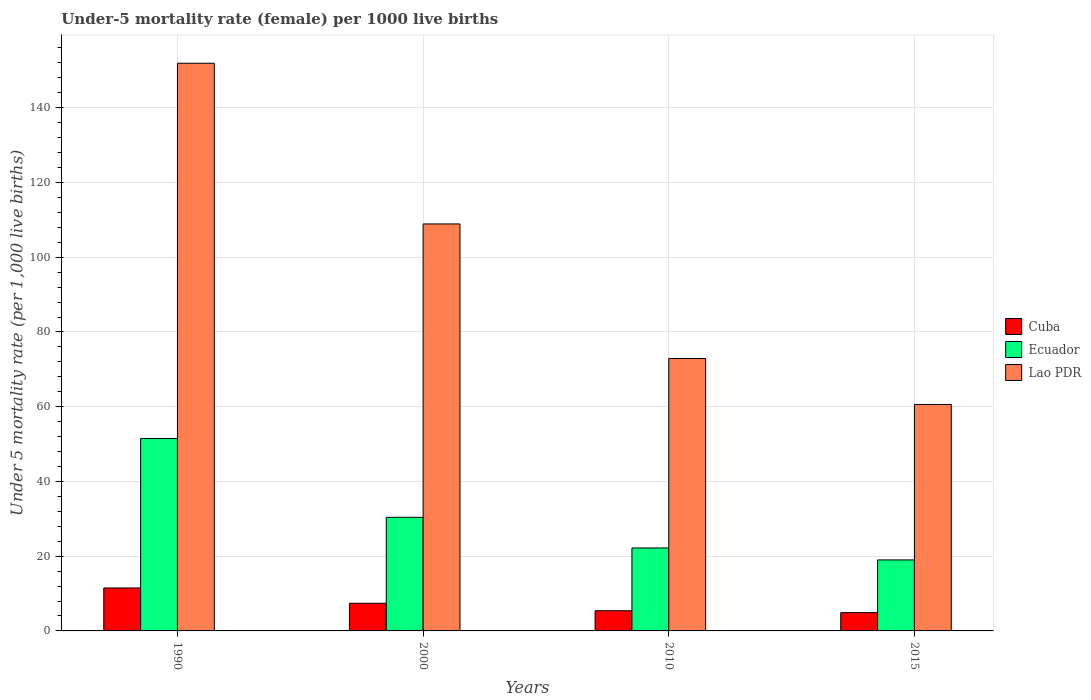How many groups of bars are there?
Your answer should be very brief. 4. Are the number of bars on each tick of the X-axis equal?
Keep it short and to the point. Yes. How many bars are there on the 3rd tick from the left?
Your answer should be very brief. 3. How many bars are there on the 4th tick from the right?
Offer a very short reply. 3. What is the under-five mortality rate in Cuba in 2000?
Offer a very short reply. 7.4. Across all years, what is the maximum under-five mortality rate in Ecuador?
Keep it short and to the point. 51.5. Across all years, what is the minimum under-five mortality rate in Lao PDR?
Your answer should be very brief. 60.6. In which year was the under-five mortality rate in Ecuador minimum?
Your answer should be very brief. 2015. What is the total under-five mortality rate in Lao PDR in the graph?
Provide a short and direct response. 394.3. What is the difference between the under-five mortality rate in Lao PDR in 1990 and that in 2015?
Provide a succinct answer. 91.3. What is the difference between the under-five mortality rate in Lao PDR in 2010 and the under-five mortality rate in Cuba in 1990?
Keep it short and to the point. 61.4. What is the average under-five mortality rate in Lao PDR per year?
Offer a very short reply. 98.58. In how many years, is the under-five mortality rate in Ecuador greater than 28?
Make the answer very short. 2. What is the ratio of the under-five mortality rate in Ecuador in 2010 to that in 2015?
Make the answer very short. 1.17. Is the under-five mortality rate in Ecuador in 1990 less than that in 2000?
Ensure brevity in your answer.  No. Is the difference between the under-five mortality rate in Ecuador in 1990 and 2010 greater than the difference between the under-five mortality rate in Cuba in 1990 and 2010?
Offer a terse response. Yes. What is the difference between the highest and the lowest under-five mortality rate in Ecuador?
Your answer should be compact. 32.5. In how many years, is the under-five mortality rate in Lao PDR greater than the average under-five mortality rate in Lao PDR taken over all years?
Provide a short and direct response. 2. What does the 3rd bar from the left in 2010 represents?
Your answer should be very brief. Lao PDR. What does the 2nd bar from the right in 1990 represents?
Your answer should be very brief. Ecuador. How many bars are there?
Ensure brevity in your answer.  12. Are all the bars in the graph horizontal?
Your answer should be compact. No. Are the values on the major ticks of Y-axis written in scientific E-notation?
Your answer should be compact. No. How many legend labels are there?
Provide a succinct answer. 3. How are the legend labels stacked?
Your answer should be compact. Vertical. What is the title of the graph?
Provide a short and direct response. Under-5 mortality rate (female) per 1000 live births. What is the label or title of the X-axis?
Offer a very short reply. Years. What is the label or title of the Y-axis?
Make the answer very short. Under 5 mortality rate (per 1,0 live births). What is the Under 5 mortality rate (per 1,000 live births) of Ecuador in 1990?
Ensure brevity in your answer.  51.5. What is the Under 5 mortality rate (per 1,000 live births) of Lao PDR in 1990?
Your answer should be very brief. 151.9. What is the Under 5 mortality rate (per 1,000 live births) in Ecuador in 2000?
Offer a very short reply. 30.4. What is the Under 5 mortality rate (per 1,000 live births) in Lao PDR in 2000?
Ensure brevity in your answer.  108.9. What is the Under 5 mortality rate (per 1,000 live births) of Cuba in 2010?
Your answer should be compact. 5.4. What is the Under 5 mortality rate (per 1,000 live births) of Ecuador in 2010?
Offer a terse response. 22.2. What is the Under 5 mortality rate (per 1,000 live births) of Lao PDR in 2010?
Your answer should be compact. 72.9. What is the Under 5 mortality rate (per 1,000 live births) in Cuba in 2015?
Give a very brief answer. 4.9. What is the Under 5 mortality rate (per 1,000 live births) in Ecuador in 2015?
Keep it short and to the point. 19. What is the Under 5 mortality rate (per 1,000 live births) in Lao PDR in 2015?
Give a very brief answer. 60.6. Across all years, what is the maximum Under 5 mortality rate (per 1,000 live births) of Ecuador?
Your response must be concise. 51.5. Across all years, what is the maximum Under 5 mortality rate (per 1,000 live births) in Lao PDR?
Ensure brevity in your answer.  151.9. Across all years, what is the minimum Under 5 mortality rate (per 1,000 live births) of Ecuador?
Offer a terse response. 19. Across all years, what is the minimum Under 5 mortality rate (per 1,000 live births) of Lao PDR?
Your answer should be compact. 60.6. What is the total Under 5 mortality rate (per 1,000 live births) in Cuba in the graph?
Ensure brevity in your answer.  29.2. What is the total Under 5 mortality rate (per 1,000 live births) of Ecuador in the graph?
Provide a short and direct response. 123.1. What is the total Under 5 mortality rate (per 1,000 live births) of Lao PDR in the graph?
Provide a short and direct response. 394.3. What is the difference between the Under 5 mortality rate (per 1,000 live births) of Cuba in 1990 and that in 2000?
Make the answer very short. 4.1. What is the difference between the Under 5 mortality rate (per 1,000 live births) of Ecuador in 1990 and that in 2000?
Your answer should be very brief. 21.1. What is the difference between the Under 5 mortality rate (per 1,000 live births) of Cuba in 1990 and that in 2010?
Your answer should be compact. 6.1. What is the difference between the Under 5 mortality rate (per 1,000 live births) of Ecuador in 1990 and that in 2010?
Your answer should be very brief. 29.3. What is the difference between the Under 5 mortality rate (per 1,000 live births) of Lao PDR in 1990 and that in 2010?
Ensure brevity in your answer.  79. What is the difference between the Under 5 mortality rate (per 1,000 live births) in Cuba in 1990 and that in 2015?
Your response must be concise. 6.6. What is the difference between the Under 5 mortality rate (per 1,000 live births) of Ecuador in 1990 and that in 2015?
Keep it short and to the point. 32.5. What is the difference between the Under 5 mortality rate (per 1,000 live births) in Lao PDR in 1990 and that in 2015?
Offer a terse response. 91.3. What is the difference between the Under 5 mortality rate (per 1,000 live births) in Ecuador in 2000 and that in 2010?
Give a very brief answer. 8.2. What is the difference between the Under 5 mortality rate (per 1,000 live births) in Lao PDR in 2000 and that in 2010?
Offer a terse response. 36. What is the difference between the Under 5 mortality rate (per 1,000 live births) of Cuba in 2000 and that in 2015?
Make the answer very short. 2.5. What is the difference between the Under 5 mortality rate (per 1,000 live births) in Ecuador in 2000 and that in 2015?
Keep it short and to the point. 11.4. What is the difference between the Under 5 mortality rate (per 1,000 live births) in Lao PDR in 2000 and that in 2015?
Your answer should be very brief. 48.3. What is the difference between the Under 5 mortality rate (per 1,000 live births) of Cuba in 2010 and that in 2015?
Give a very brief answer. 0.5. What is the difference between the Under 5 mortality rate (per 1,000 live births) in Ecuador in 2010 and that in 2015?
Give a very brief answer. 3.2. What is the difference between the Under 5 mortality rate (per 1,000 live births) of Cuba in 1990 and the Under 5 mortality rate (per 1,000 live births) of Ecuador in 2000?
Make the answer very short. -18.9. What is the difference between the Under 5 mortality rate (per 1,000 live births) in Cuba in 1990 and the Under 5 mortality rate (per 1,000 live births) in Lao PDR in 2000?
Ensure brevity in your answer.  -97.4. What is the difference between the Under 5 mortality rate (per 1,000 live births) of Ecuador in 1990 and the Under 5 mortality rate (per 1,000 live births) of Lao PDR in 2000?
Offer a terse response. -57.4. What is the difference between the Under 5 mortality rate (per 1,000 live births) of Cuba in 1990 and the Under 5 mortality rate (per 1,000 live births) of Ecuador in 2010?
Your response must be concise. -10.7. What is the difference between the Under 5 mortality rate (per 1,000 live births) in Cuba in 1990 and the Under 5 mortality rate (per 1,000 live births) in Lao PDR in 2010?
Make the answer very short. -61.4. What is the difference between the Under 5 mortality rate (per 1,000 live births) of Ecuador in 1990 and the Under 5 mortality rate (per 1,000 live births) of Lao PDR in 2010?
Keep it short and to the point. -21.4. What is the difference between the Under 5 mortality rate (per 1,000 live births) of Cuba in 1990 and the Under 5 mortality rate (per 1,000 live births) of Lao PDR in 2015?
Make the answer very short. -49.1. What is the difference between the Under 5 mortality rate (per 1,000 live births) of Ecuador in 1990 and the Under 5 mortality rate (per 1,000 live births) of Lao PDR in 2015?
Ensure brevity in your answer.  -9.1. What is the difference between the Under 5 mortality rate (per 1,000 live births) of Cuba in 2000 and the Under 5 mortality rate (per 1,000 live births) of Ecuador in 2010?
Provide a short and direct response. -14.8. What is the difference between the Under 5 mortality rate (per 1,000 live births) in Cuba in 2000 and the Under 5 mortality rate (per 1,000 live births) in Lao PDR in 2010?
Provide a succinct answer. -65.5. What is the difference between the Under 5 mortality rate (per 1,000 live births) in Ecuador in 2000 and the Under 5 mortality rate (per 1,000 live births) in Lao PDR in 2010?
Give a very brief answer. -42.5. What is the difference between the Under 5 mortality rate (per 1,000 live births) in Cuba in 2000 and the Under 5 mortality rate (per 1,000 live births) in Lao PDR in 2015?
Your answer should be compact. -53.2. What is the difference between the Under 5 mortality rate (per 1,000 live births) in Ecuador in 2000 and the Under 5 mortality rate (per 1,000 live births) in Lao PDR in 2015?
Provide a succinct answer. -30.2. What is the difference between the Under 5 mortality rate (per 1,000 live births) of Cuba in 2010 and the Under 5 mortality rate (per 1,000 live births) of Ecuador in 2015?
Your answer should be compact. -13.6. What is the difference between the Under 5 mortality rate (per 1,000 live births) of Cuba in 2010 and the Under 5 mortality rate (per 1,000 live births) of Lao PDR in 2015?
Provide a short and direct response. -55.2. What is the difference between the Under 5 mortality rate (per 1,000 live births) of Ecuador in 2010 and the Under 5 mortality rate (per 1,000 live births) of Lao PDR in 2015?
Provide a succinct answer. -38.4. What is the average Under 5 mortality rate (per 1,000 live births) of Cuba per year?
Keep it short and to the point. 7.3. What is the average Under 5 mortality rate (per 1,000 live births) of Ecuador per year?
Your answer should be very brief. 30.77. What is the average Under 5 mortality rate (per 1,000 live births) in Lao PDR per year?
Make the answer very short. 98.58. In the year 1990, what is the difference between the Under 5 mortality rate (per 1,000 live births) of Cuba and Under 5 mortality rate (per 1,000 live births) of Lao PDR?
Ensure brevity in your answer.  -140.4. In the year 1990, what is the difference between the Under 5 mortality rate (per 1,000 live births) in Ecuador and Under 5 mortality rate (per 1,000 live births) in Lao PDR?
Your answer should be very brief. -100.4. In the year 2000, what is the difference between the Under 5 mortality rate (per 1,000 live births) of Cuba and Under 5 mortality rate (per 1,000 live births) of Lao PDR?
Your answer should be very brief. -101.5. In the year 2000, what is the difference between the Under 5 mortality rate (per 1,000 live births) of Ecuador and Under 5 mortality rate (per 1,000 live births) of Lao PDR?
Give a very brief answer. -78.5. In the year 2010, what is the difference between the Under 5 mortality rate (per 1,000 live births) of Cuba and Under 5 mortality rate (per 1,000 live births) of Ecuador?
Make the answer very short. -16.8. In the year 2010, what is the difference between the Under 5 mortality rate (per 1,000 live births) of Cuba and Under 5 mortality rate (per 1,000 live births) of Lao PDR?
Your response must be concise. -67.5. In the year 2010, what is the difference between the Under 5 mortality rate (per 1,000 live births) of Ecuador and Under 5 mortality rate (per 1,000 live births) of Lao PDR?
Give a very brief answer. -50.7. In the year 2015, what is the difference between the Under 5 mortality rate (per 1,000 live births) in Cuba and Under 5 mortality rate (per 1,000 live births) in Ecuador?
Provide a short and direct response. -14.1. In the year 2015, what is the difference between the Under 5 mortality rate (per 1,000 live births) of Cuba and Under 5 mortality rate (per 1,000 live births) of Lao PDR?
Your answer should be compact. -55.7. In the year 2015, what is the difference between the Under 5 mortality rate (per 1,000 live births) in Ecuador and Under 5 mortality rate (per 1,000 live births) in Lao PDR?
Offer a terse response. -41.6. What is the ratio of the Under 5 mortality rate (per 1,000 live births) in Cuba in 1990 to that in 2000?
Provide a succinct answer. 1.55. What is the ratio of the Under 5 mortality rate (per 1,000 live births) of Ecuador in 1990 to that in 2000?
Your answer should be compact. 1.69. What is the ratio of the Under 5 mortality rate (per 1,000 live births) of Lao PDR in 1990 to that in 2000?
Ensure brevity in your answer.  1.39. What is the ratio of the Under 5 mortality rate (per 1,000 live births) of Cuba in 1990 to that in 2010?
Your answer should be compact. 2.13. What is the ratio of the Under 5 mortality rate (per 1,000 live births) of Ecuador in 1990 to that in 2010?
Offer a terse response. 2.32. What is the ratio of the Under 5 mortality rate (per 1,000 live births) in Lao PDR in 1990 to that in 2010?
Offer a terse response. 2.08. What is the ratio of the Under 5 mortality rate (per 1,000 live births) in Cuba in 1990 to that in 2015?
Provide a short and direct response. 2.35. What is the ratio of the Under 5 mortality rate (per 1,000 live births) in Ecuador in 1990 to that in 2015?
Offer a terse response. 2.71. What is the ratio of the Under 5 mortality rate (per 1,000 live births) in Lao PDR in 1990 to that in 2015?
Your answer should be compact. 2.51. What is the ratio of the Under 5 mortality rate (per 1,000 live births) of Cuba in 2000 to that in 2010?
Keep it short and to the point. 1.37. What is the ratio of the Under 5 mortality rate (per 1,000 live births) in Ecuador in 2000 to that in 2010?
Ensure brevity in your answer.  1.37. What is the ratio of the Under 5 mortality rate (per 1,000 live births) of Lao PDR in 2000 to that in 2010?
Ensure brevity in your answer.  1.49. What is the ratio of the Under 5 mortality rate (per 1,000 live births) of Cuba in 2000 to that in 2015?
Keep it short and to the point. 1.51. What is the ratio of the Under 5 mortality rate (per 1,000 live births) in Lao PDR in 2000 to that in 2015?
Your answer should be compact. 1.8. What is the ratio of the Under 5 mortality rate (per 1,000 live births) of Cuba in 2010 to that in 2015?
Your answer should be very brief. 1.1. What is the ratio of the Under 5 mortality rate (per 1,000 live births) of Ecuador in 2010 to that in 2015?
Your answer should be compact. 1.17. What is the ratio of the Under 5 mortality rate (per 1,000 live births) of Lao PDR in 2010 to that in 2015?
Offer a terse response. 1.2. What is the difference between the highest and the second highest Under 5 mortality rate (per 1,000 live births) of Ecuador?
Offer a terse response. 21.1. What is the difference between the highest and the lowest Under 5 mortality rate (per 1,000 live births) of Ecuador?
Make the answer very short. 32.5. What is the difference between the highest and the lowest Under 5 mortality rate (per 1,000 live births) of Lao PDR?
Make the answer very short. 91.3. 